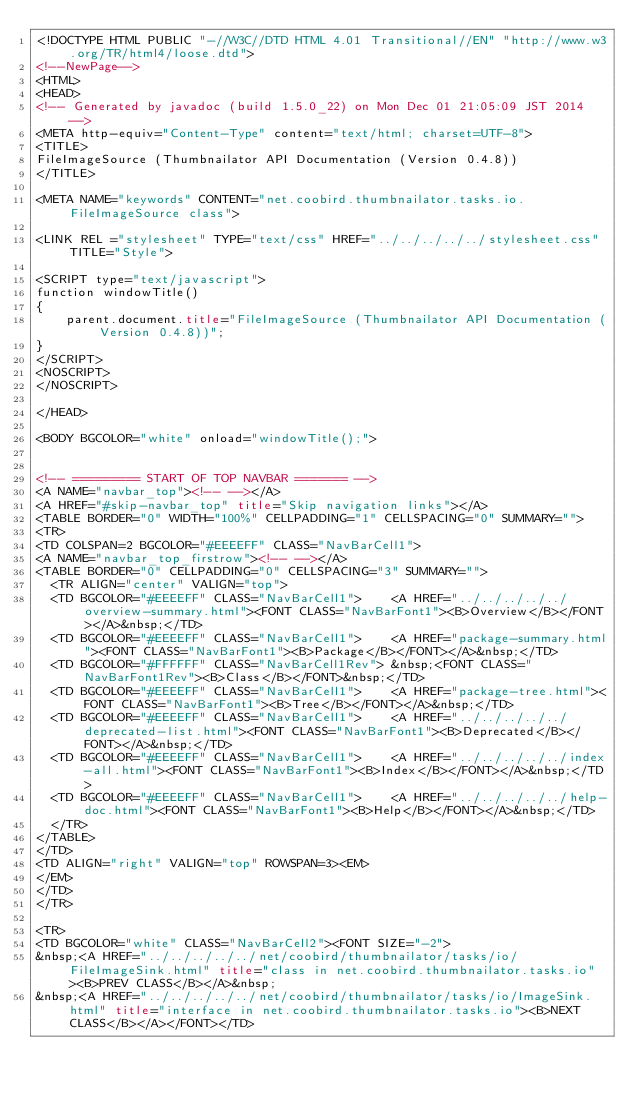<code> <loc_0><loc_0><loc_500><loc_500><_HTML_><!DOCTYPE HTML PUBLIC "-//W3C//DTD HTML 4.01 Transitional//EN" "http://www.w3.org/TR/html4/loose.dtd">
<!--NewPage-->
<HTML>
<HEAD>
<!-- Generated by javadoc (build 1.5.0_22) on Mon Dec 01 21:05:09 JST 2014 -->
<META http-equiv="Content-Type" content="text/html; charset=UTF-8">
<TITLE>
FileImageSource (Thumbnailator API Documentation (Version 0.4.8))
</TITLE>

<META NAME="keywords" CONTENT="net.coobird.thumbnailator.tasks.io.FileImageSource class">

<LINK REL ="stylesheet" TYPE="text/css" HREF="../../../../../stylesheet.css" TITLE="Style">

<SCRIPT type="text/javascript">
function windowTitle()
{
    parent.document.title="FileImageSource (Thumbnailator API Documentation (Version 0.4.8))";
}
</SCRIPT>
<NOSCRIPT>
</NOSCRIPT>

</HEAD>

<BODY BGCOLOR="white" onload="windowTitle();">


<!-- ========= START OF TOP NAVBAR ======= -->
<A NAME="navbar_top"><!-- --></A>
<A HREF="#skip-navbar_top" title="Skip navigation links"></A>
<TABLE BORDER="0" WIDTH="100%" CELLPADDING="1" CELLSPACING="0" SUMMARY="">
<TR>
<TD COLSPAN=2 BGCOLOR="#EEEEFF" CLASS="NavBarCell1">
<A NAME="navbar_top_firstrow"><!-- --></A>
<TABLE BORDER="0" CELLPADDING="0" CELLSPACING="3" SUMMARY="">
  <TR ALIGN="center" VALIGN="top">
  <TD BGCOLOR="#EEEEFF" CLASS="NavBarCell1">    <A HREF="../../../../../overview-summary.html"><FONT CLASS="NavBarFont1"><B>Overview</B></FONT></A>&nbsp;</TD>
  <TD BGCOLOR="#EEEEFF" CLASS="NavBarCell1">    <A HREF="package-summary.html"><FONT CLASS="NavBarFont1"><B>Package</B></FONT></A>&nbsp;</TD>
  <TD BGCOLOR="#FFFFFF" CLASS="NavBarCell1Rev"> &nbsp;<FONT CLASS="NavBarFont1Rev"><B>Class</B></FONT>&nbsp;</TD>
  <TD BGCOLOR="#EEEEFF" CLASS="NavBarCell1">    <A HREF="package-tree.html"><FONT CLASS="NavBarFont1"><B>Tree</B></FONT></A>&nbsp;</TD>
  <TD BGCOLOR="#EEEEFF" CLASS="NavBarCell1">    <A HREF="../../../../../deprecated-list.html"><FONT CLASS="NavBarFont1"><B>Deprecated</B></FONT></A>&nbsp;</TD>
  <TD BGCOLOR="#EEEEFF" CLASS="NavBarCell1">    <A HREF="../../../../../index-all.html"><FONT CLASS="NavBarFont1"><B>Index</B></FONT></A>&nbsp;</TD>
  <TD BGCOLOR="#EEEEFF" CLASS="NavBarCell1">    <A HREF="../../../../../help-doc.html"><FONT CLASS="NavBarFont1"><B>Help</B></FONT></A>&nbsp;</TD>
  </TR>
</TABLE>
</TD>
<TD ALIGN="right" VALIGN="top" ROWSPAN=3><EM>
</EM>
</TD>
</TR>

<TR>
<TD BGCOLOR="white" CLASS="NavBarCell2"><FONT SIZE="-2">
&nbsp;<A HREF="../../../../../net/coobird/thumbnailator/tasks/io/FileImageSink.html" title="class in net.coobird.thumbnailator.tasks.io"><B>PREV CLASS</B></A>&nbsp;
&nbsp;<A HREF="../../../../../net/coobird/thumbnailator/tasks/io/ImageSink.html" title="interface in net.coobird.thumbnailator.tasks.io"><B>NEXT CLASS</B></A></FONT></TD></code> 